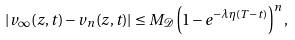<formula> <loc_0><loc_0><loc_500><loc_500>| v _ { \infty } ( z , t ) - v _ { n } ( z , t ) | \leq M _ { \mathcal { D } } \left ( 1 - e ^ { - \lambda \eta ( T - t ) } \right ) ^ { n } ,</formula> 